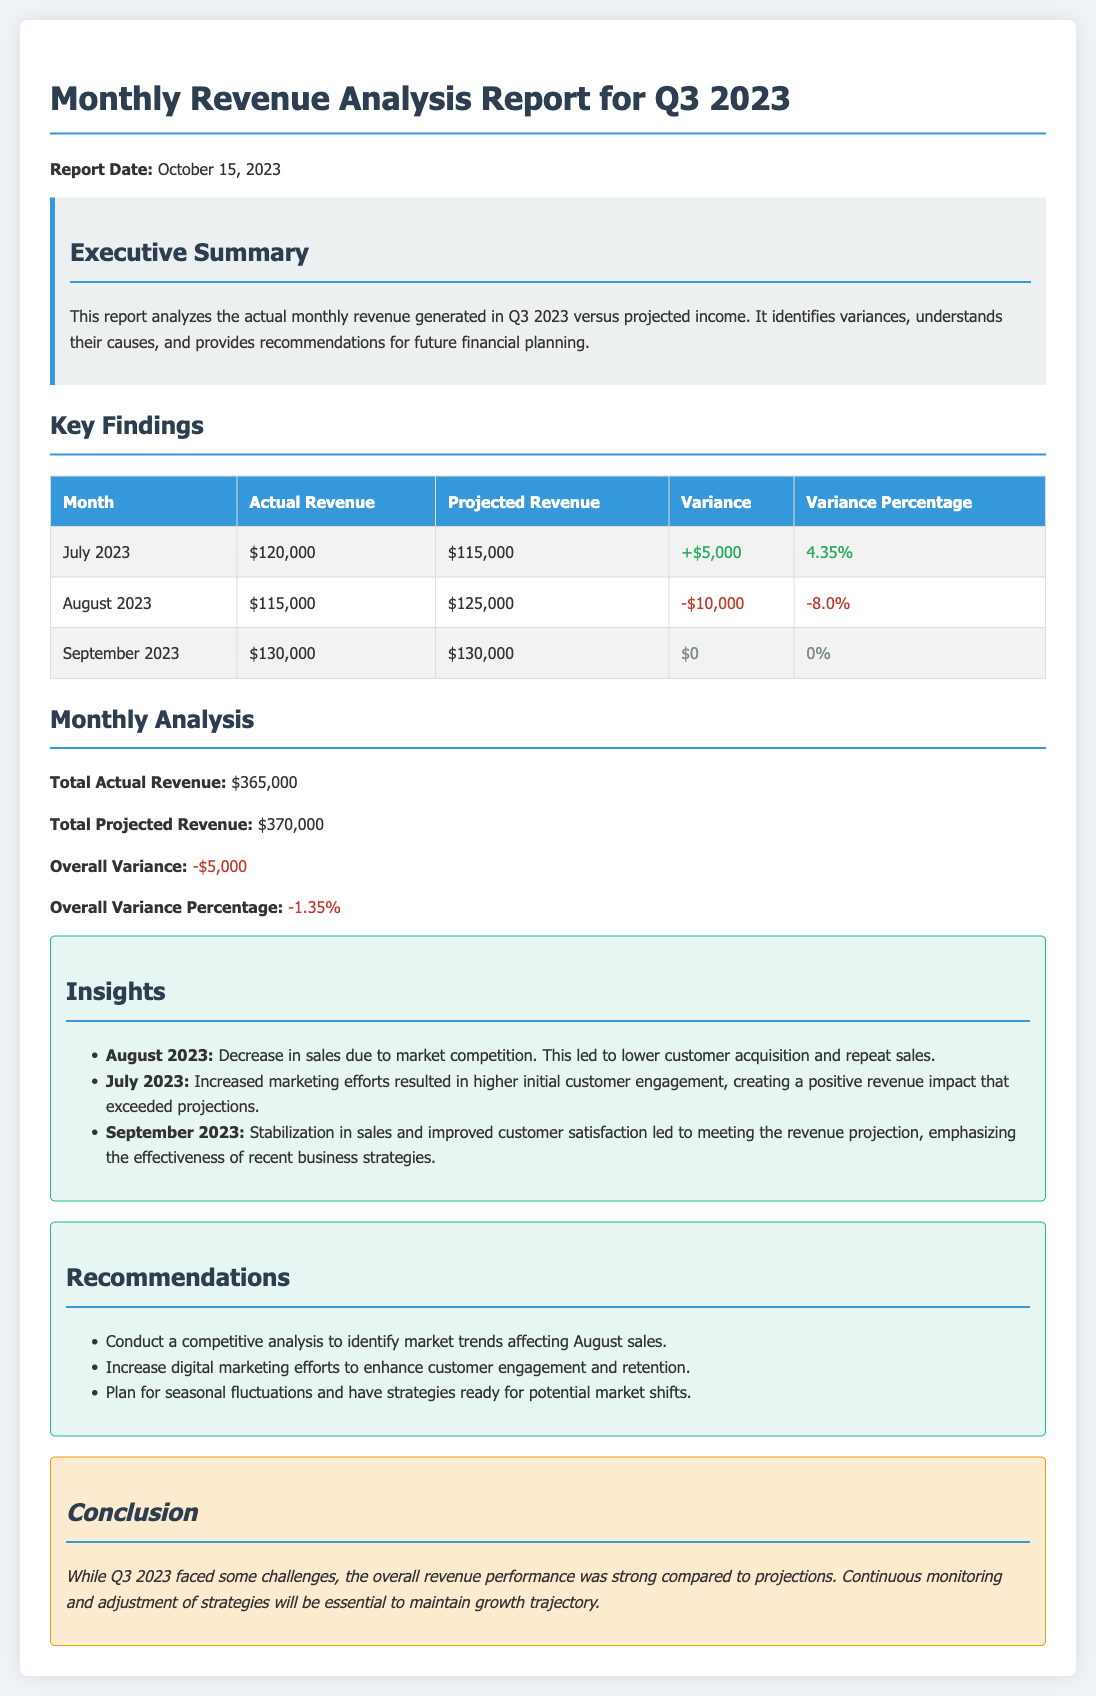What is the report date? The report date is mentioned in the introduction of the document.
Answer: October 15, 2023 What was the actual revenue for July 2023? The actual revenue for July 2023 is found in the table under the respective column.
Answer: $120,000 What is the variance for August 2023? The variance for August 2023 is listed in the table next to the actual and projected revenue figures.
Answer: -$10,000 What was the total actual revenue for Q3 2023? The total actual revenue is summarized in the 'Monthly Analysis' section of the report.
Answer: $365,000 What is the overall variance percentage for Q3 2023? The overall variance percentage is indicated at the end of the 'Monthly Analysis' section.
Answer: -1.35% What was one reason for the sales decrease in August 2023? The insights section provides explanations for the variances, including specific factors affecting performance.
Answer: Market competition What recommendation is suggested for improving revenue? The recommendations section lists specific actions to enhance future performance.
Answer: Increase digital marketing efforts Which month had no variance in revenue? The table shows the months with variances; identifying the one with zero change provides the answer.
Answer: September 2023 What is the title of the report? The title appears prominently at the beginning of the document.
Answer: Monthly Revenue Analysis Report for Q3 2023 